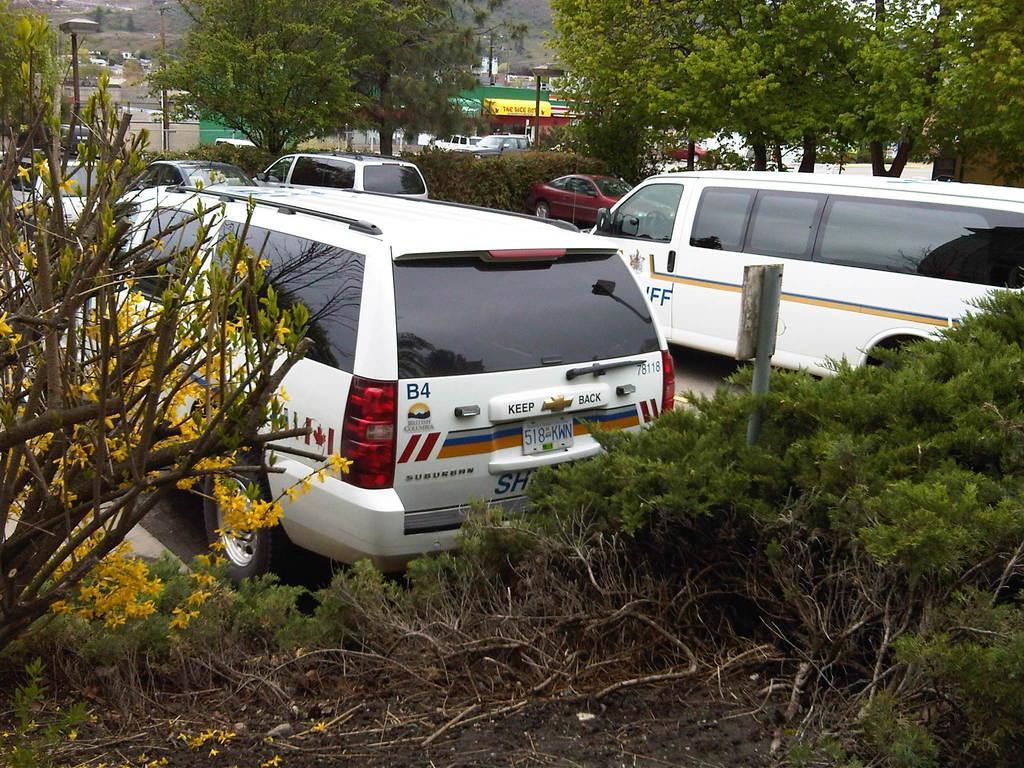Can you describe this image briefly? This image consists of vans in white color. At the bottom, there are plants. To the left, there are yellow color flowers to the plants. In the background, there are many trees. 